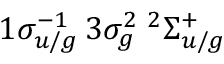Convert formula to latex. <formula><loc_0><loc_0><loc_500><loc_500>1 \sigma _ { u / g } ^ { - 1 } \, 3 \sigma _ { g } ^ { 2 } \, ^ { 2 } \Sigma _ { u / g } ^ { + }</formula> 